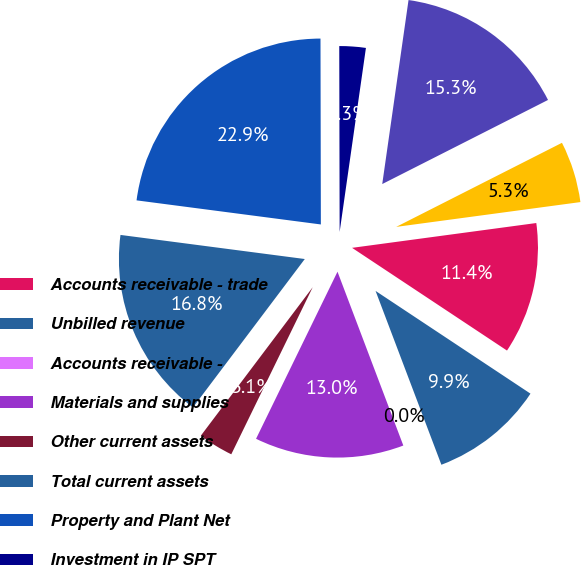Convert chart to OTSL. <chart><loc_0><loc_0><loc_500><loc_500><pie_chart><fcel>Accounts receivable - trade<fcel>Unbilled revenue<fcel>Accounts receivable -<fcel>Materials and supplies<fcel>Other current assets<fcel>Total current assets<fcel>Property and Plant Net<fcel>Investment in IP SPT<fcel>Goodwill<fcel>Other assets<nl><fcel>11.45%<fcel>9.92%<fcel>0.0%<fcel>12.98%<fcel>3.06%<fcel>16.79%<fcel>22.9%<fcel>2.29%<fcel>15.27%<fcel>5.34%<nl></chart> 